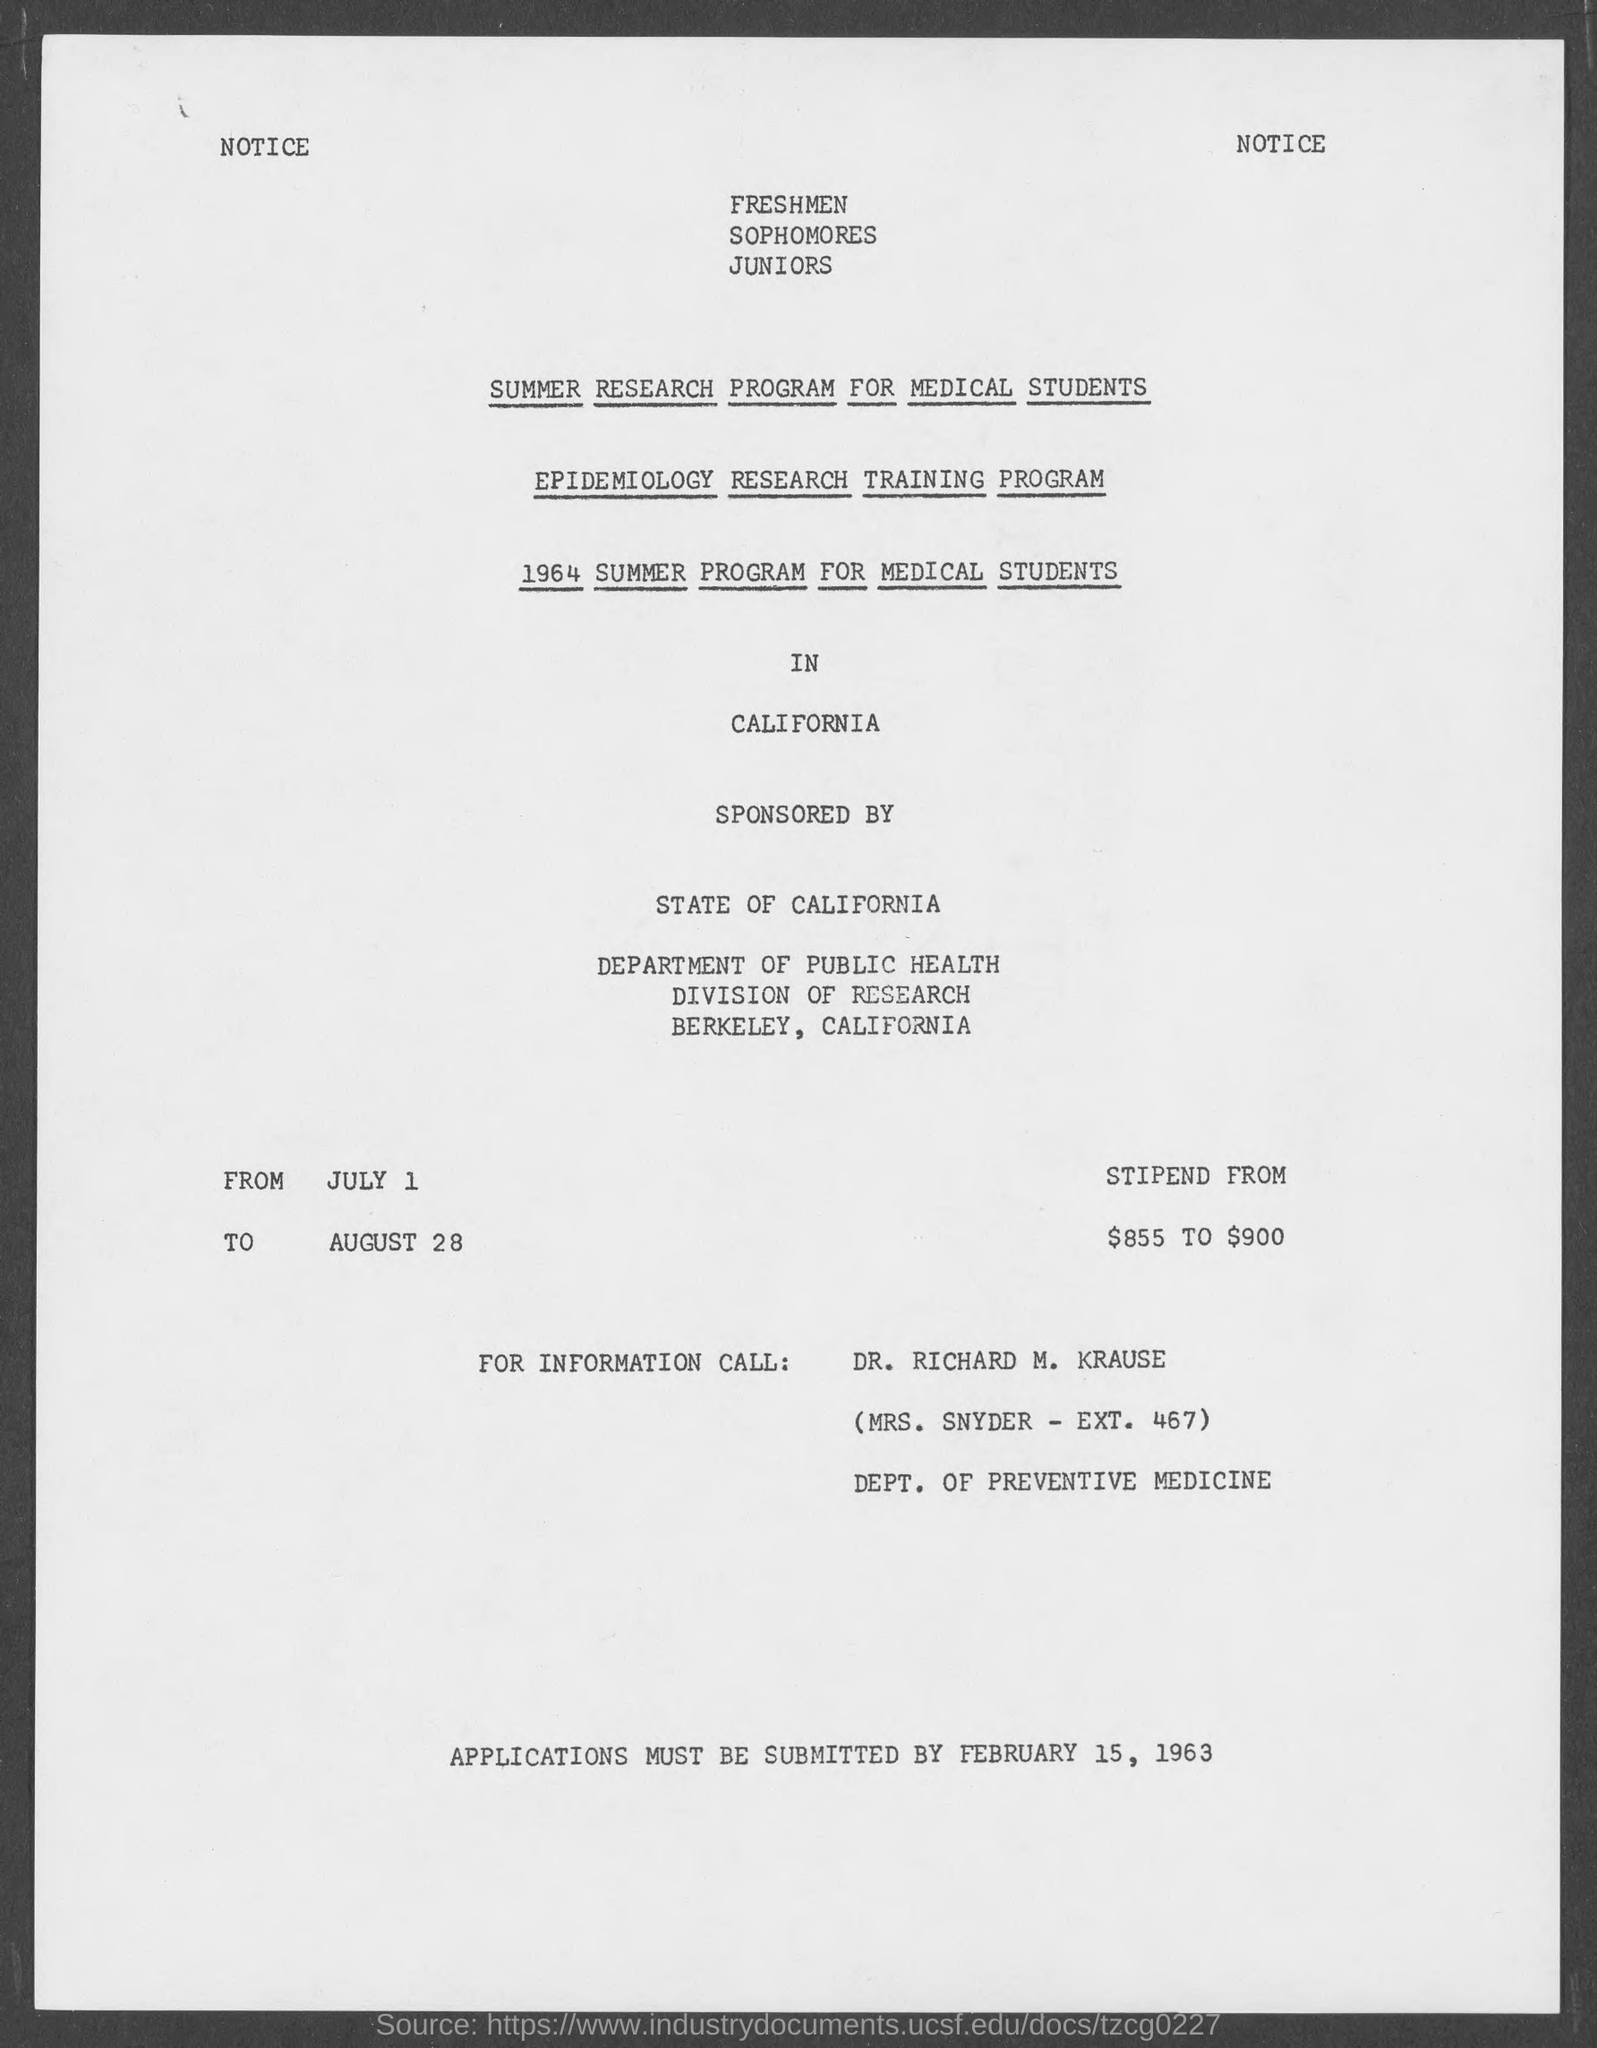What is the last date for submission of applications ?
Your answer should be compact. February 15, 1963. 